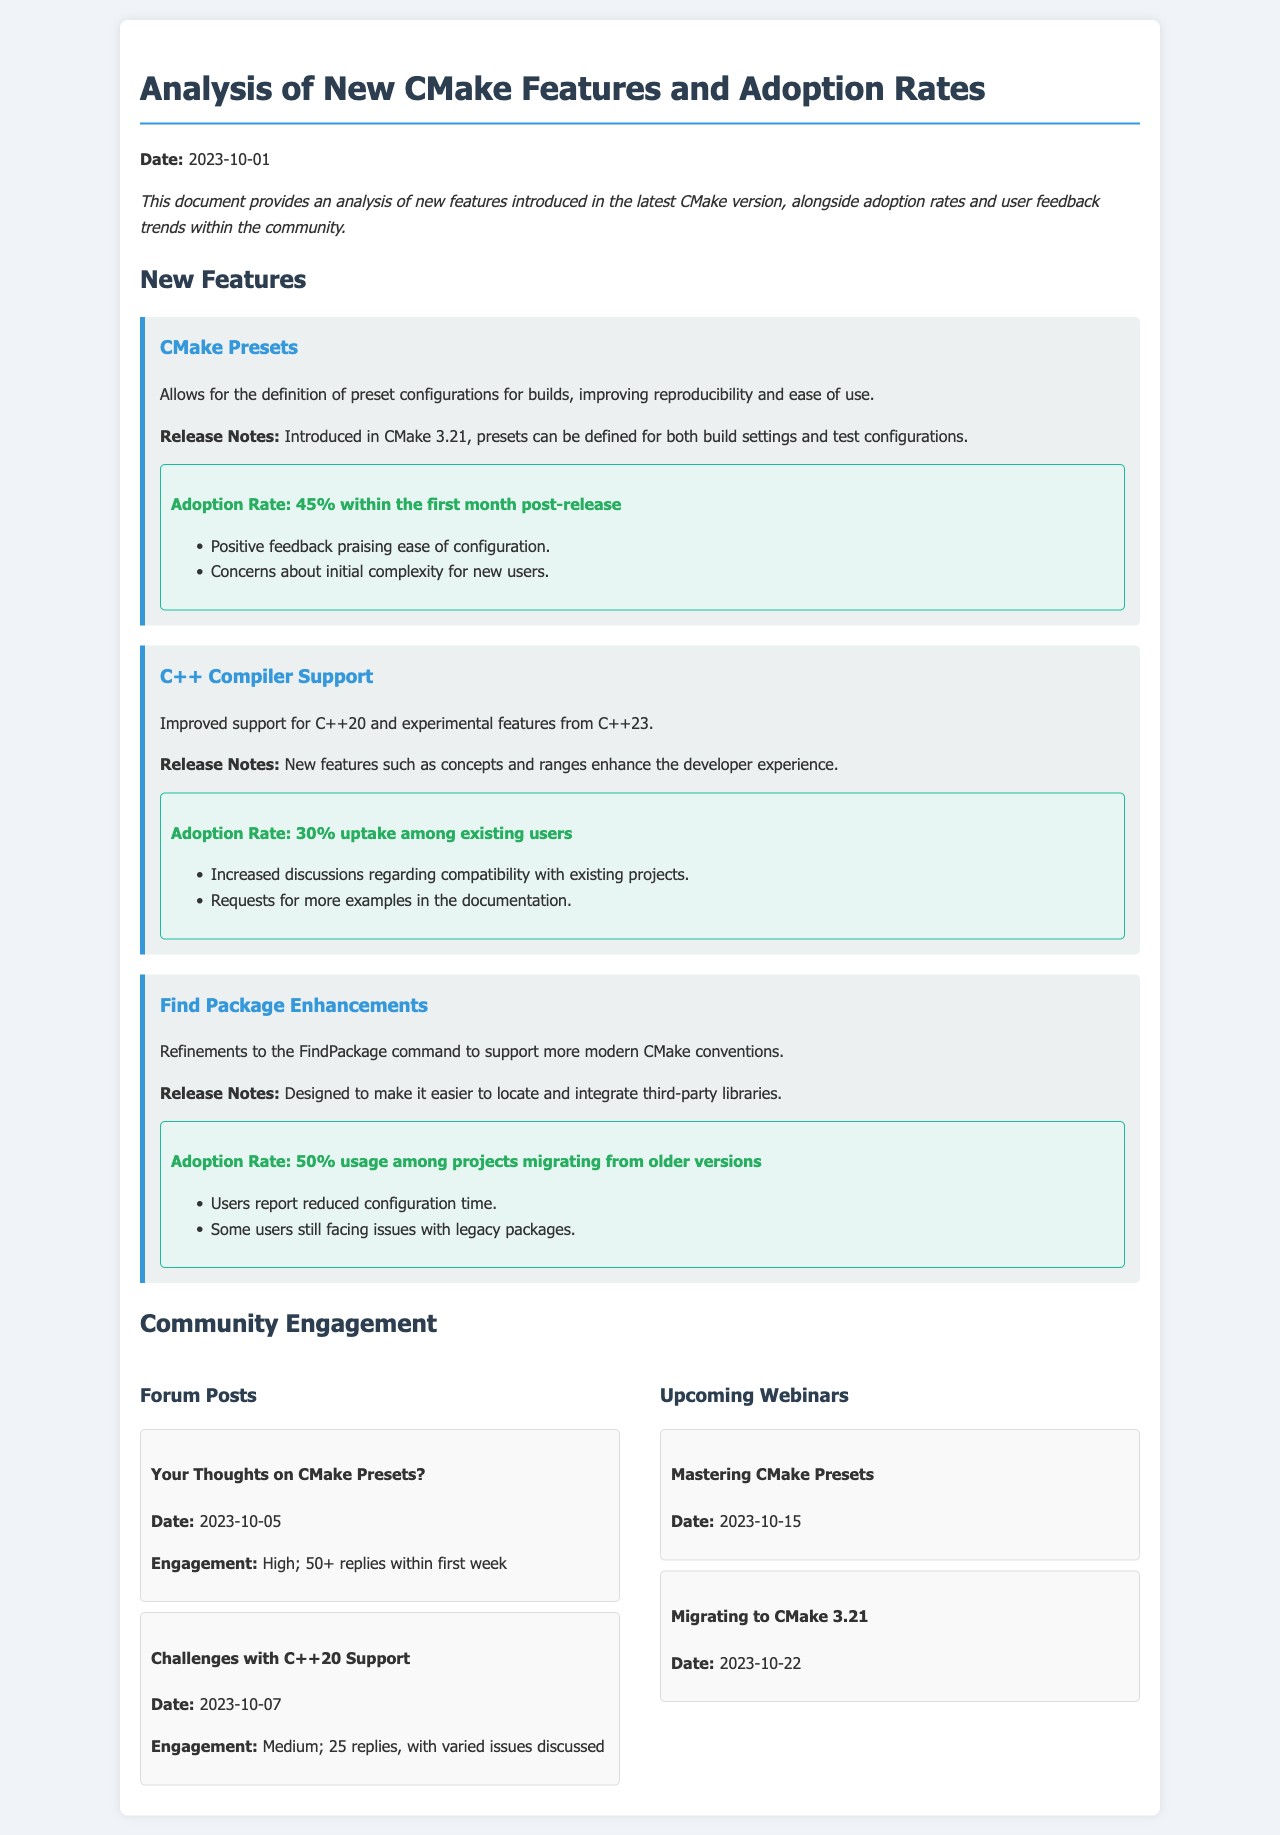What is the adoption rate for CMake Presets? The adoption rate for CMake Presets is mentioned in the feedback section as 45% within the first month post-release.
Answer: 45% What feature supports improved compatibility with C++20? The feature that supports improved compatibility with C++20 is titled "C++ Compiler Support," as described in the new features section.
Answer: C++ Compiler Support When was the analysis document created? The creation date of the analysis document is stated at the top as 2023-10-01.
Answer: 2023-10-01 What is the engagement level for the forum post titled "Your Thoughts on CMake Presets?" The engagement level for the forum post is described as high, with 50+ replies within the first week.
Answer: High Which feature has an adoption rate of 50%? The feature with an adoption rate of 50% is "Find Package Enhancements", as noted in the feedback section.
Answer: Find Package Enhancements What date is the webinar titled "Mastering CMake Presets" scheduled for? The date of the webinar "Mastering CMake Presets" is mentioned in the upcoming webinars section as 2023-10-15.
Answer: 2023-10-15 How many replies did the "Challenges with C++20 Support" post receive? The post "Challenges with C++20 Support" received 25 replies, which is specified in its engagement description.
Answer: 25 What is one concern mentioned about the CMake Presets feature? One concern mentioned about the CMake Presets feature is about the initial complexity for new users, as outlined in the feedback section.
Answer: Initial complexity for new users What percentage of projects has adopted the enhanced Find Package support? The enhanced Find Package support has been adopted by 50% of projects migrating from older versions, which is detailed in the feedback section.
Answer: 50% 